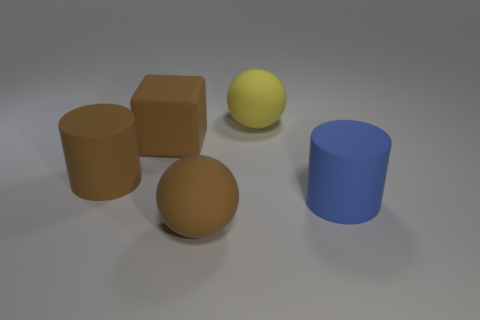Add 4 rubber things. How many objects exist? 9 Subtract all blocks. How many objects are left? 4 Add 1 big brown rubber blocks. How many big brown rubber blocks exist? 2 Subtract 0 green cylinders. How many objects are left? 5 Subtract all big cyan matte balls. Subtract all large cylinders. How many objects are left? 3 Add 3 brown matte spheres. How many brown matte spheres are left? 4 